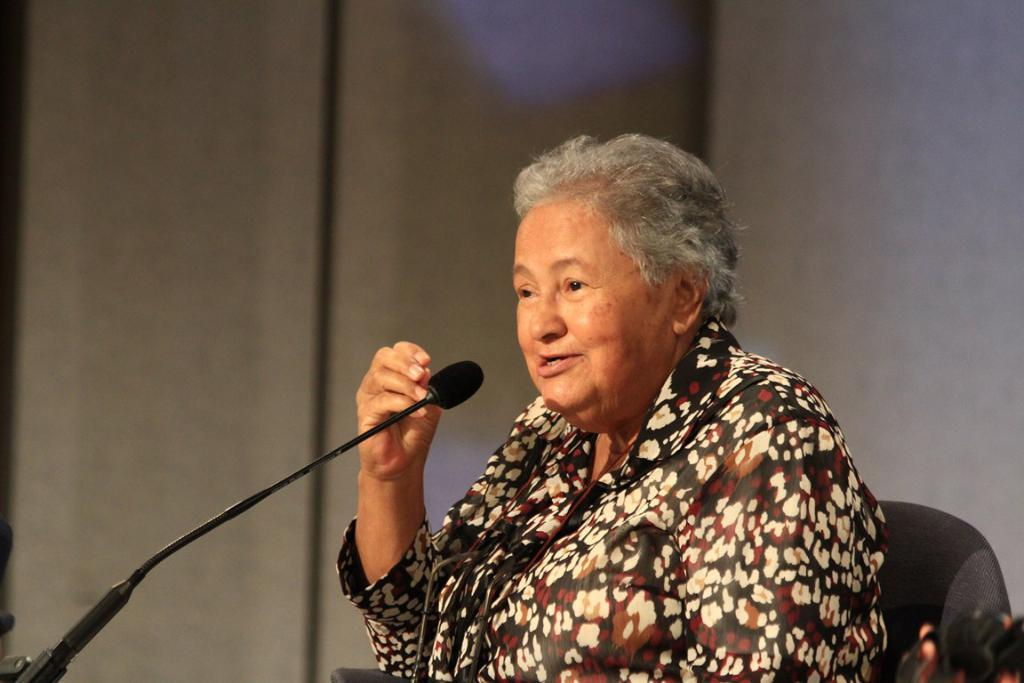Who is present in the image? There is a woman in the image. What is the woman doing in the image? The woman is sitting on a chair in the image. What object is in front of the woman? There is a mic in front of the woman. What can be seen behind the woman? There is a wall visible in the background of the image. What type of plane is the woman flying in the image? There is no plane present in the image; it features a woman sitting on a chair with a mic in front of her. What type of quiver is the woman holding in the image? There is no quiver present in the image; it only shows a woman sitting on a chair with a mic in front of her and a wall in the background. 